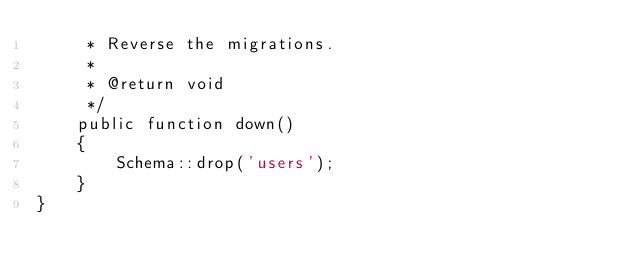Convert code to text. <code><loc_0><loc_0><loc_500><loc_500><_PHP_>     * Reverse the migrations.
     *
     * @return void
     */
    public function down()
    {
        Schema::drop('users');
    }
}
</code> 